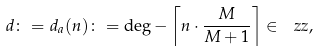<formula> <loc_0><loc_0><loc_500><loc_500>d \colon = d _ { a } ( n ) \colon = \deg - \left \lceil n \cdot \frac { M } { M + 1 } \right \rceil \in \ z z ,</formula> 